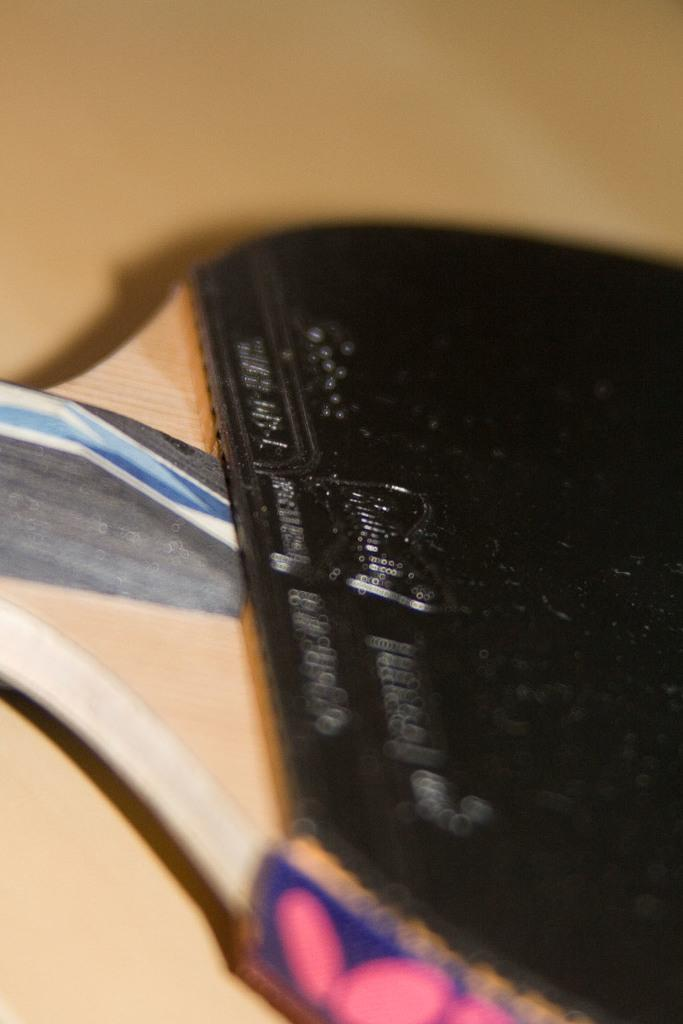What object is the main focus of the image? There is a table tennis bat in the image. What color is the table tennis bat? The table tennis bat is black in color. What can be seen in the background of the image? The background of the image is light brown in color. Can you see any baskets being used for cooking in the image? There are no baskets or cooking activities present in the image; it features a table tennis bat and a light brown background. 